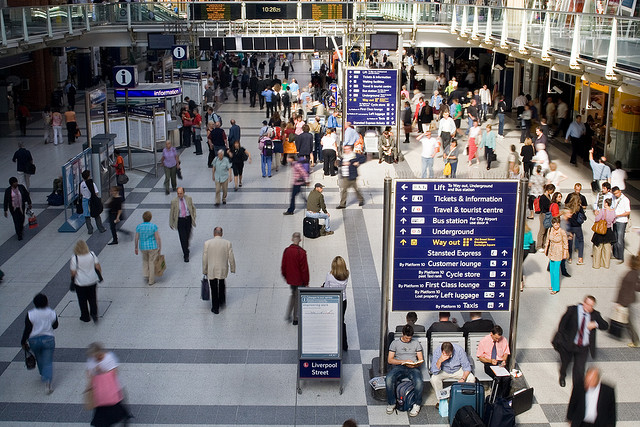<image>On the sign, which is the direction for the customer lounge? It is ambiguous which is the direction for the customer lounge on the sign. It could be straight, right, or left. What does the I over the desks? It is unknown what the 'I' over the desks represents, although it's often associated with 'information'. What does the I over the desks? I don't know what does the 'I' over the desks. It can be information or unknown. On the sign, which is the direction for the customer lounge? I don't know which is the direction for the customer lounge on the sign. It can be seen 'straight', 'left', 'right' or 'in front'. 